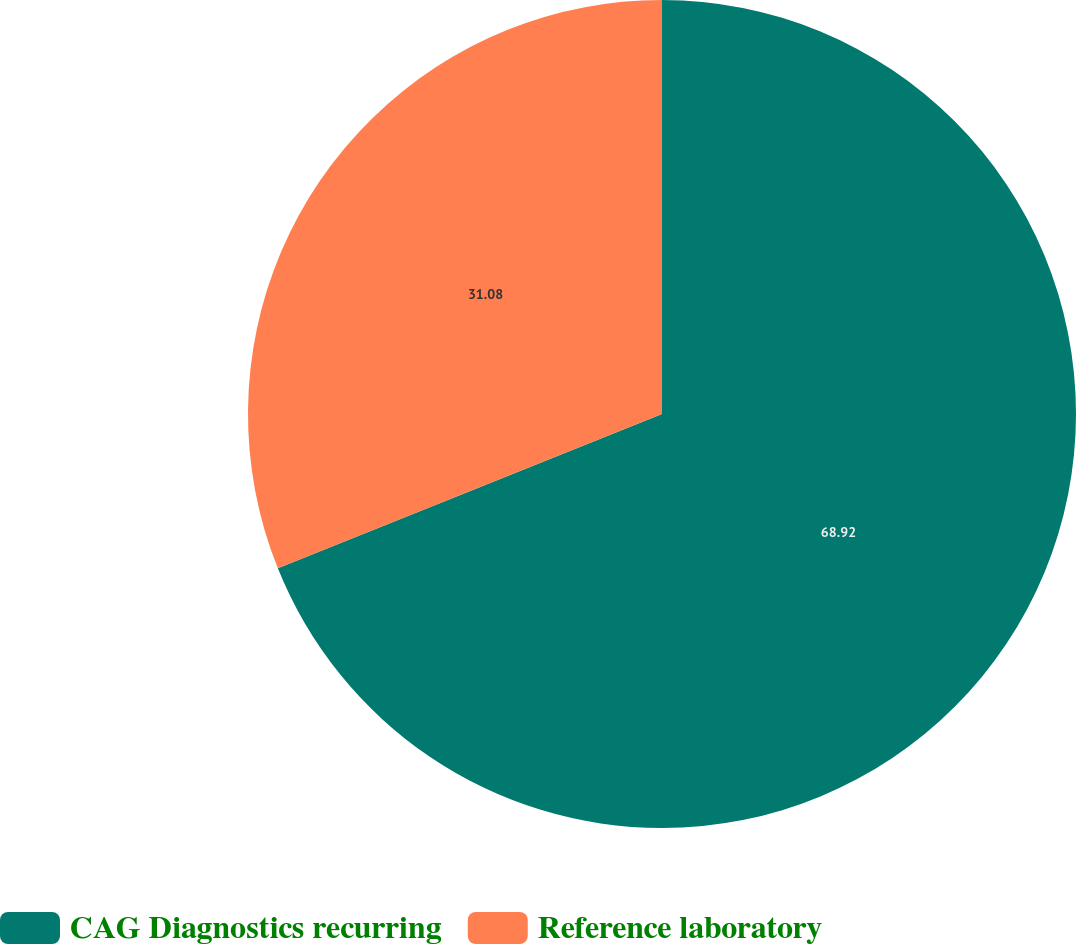Convert chart. <chart><loc_0><loc_0><loc_500><loc_500><pie_chart><fcel>CAG Diagnostics recurring<fcel>Reference laboratory<nl><fcel>68.92%<fcel>31.08%<nl></chart> 